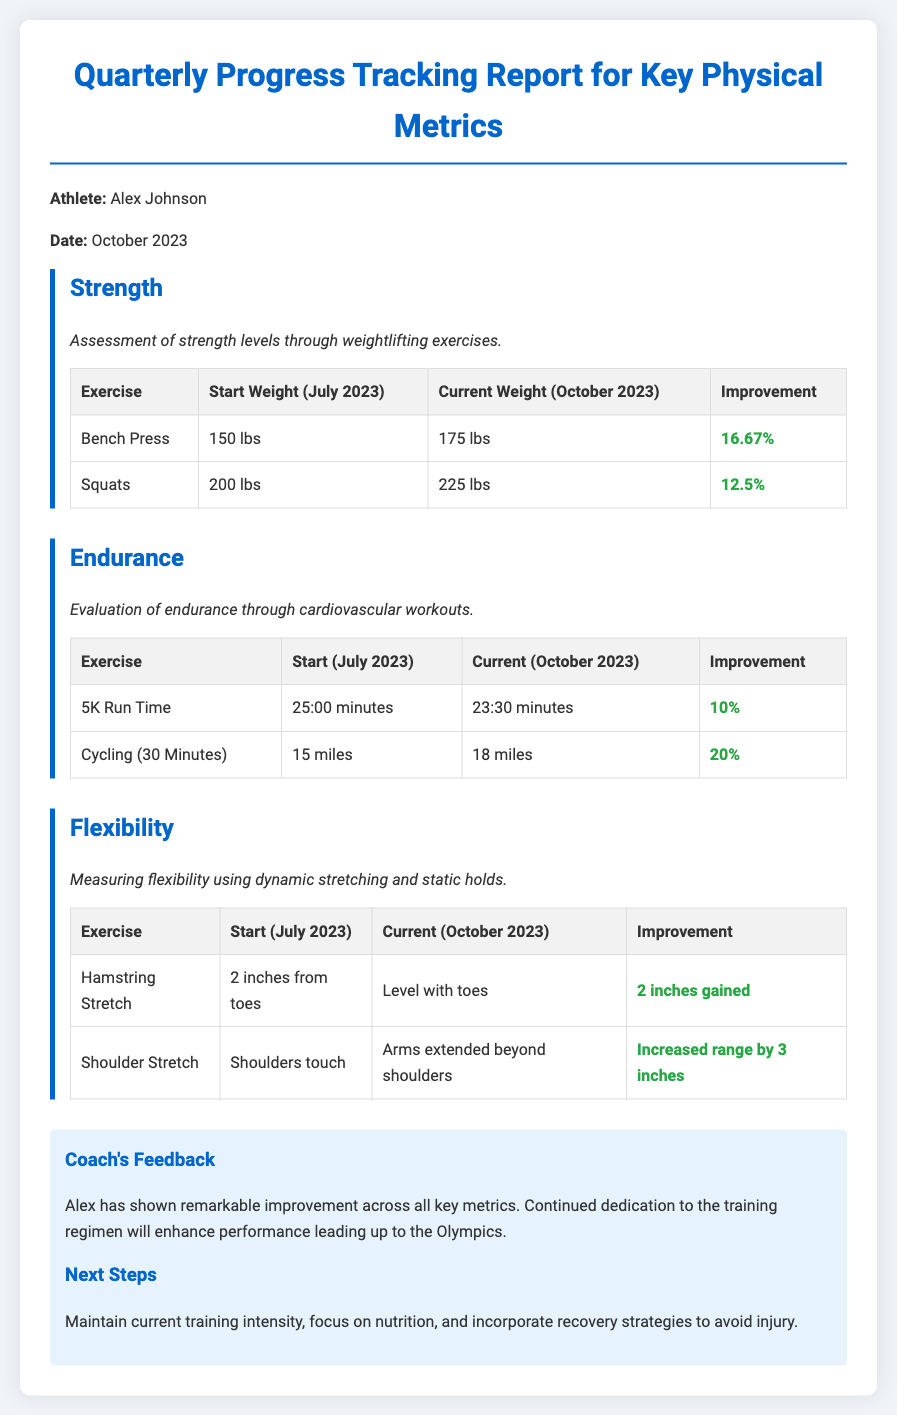What is the name of the athlete? The document states the athlete's name as Alex Johnson.
Answer: Alex Johnson What is the date of the report? The report is dated October 2023.
Answer: October 2023 What was the starting weight for the Bench Press? The starting weight for the Bench Press is listed as 150 lbs.
Answer: 150 lbs How much improvement did Alex achieve in squats? The improvement in squats is calculated as 12.5%.
Answer: 12.5% What was the current time for the 5K run? The document states the current time for the 5K run is 23:30 minutes.
Answer: 23:30 minutes What exercise gained 3 inches in flexibility? The Shoulder Stretch gained 3 inches in flexibility.
Answer: Shoulder Stretch What is the coach's overall feedback? The coach's feedback highlights remarkable improvement across all key metrics.
Answer: Remarkable improvement What next steps does the coach suggest? The coach suggests maintaining current training intensity and focusing on nutrition.
Answer: Maintain current training intensity What percentage improvement did Alex achieve in cycling? The improvement in cycling is stated as 20%.
Answer: 20% 